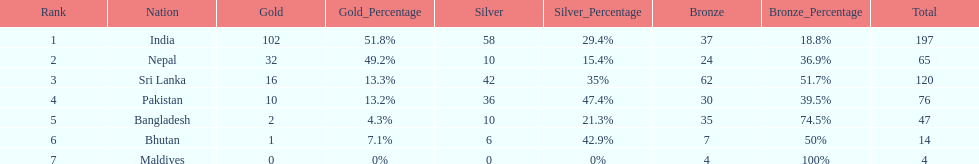Name a country listed in the table, other than india? Nepal. 